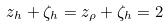<formula> <loc_0><loc_0><loc_500><loc_500>z _ { h } + \zeta _ { h } = z _ { \rho } + \zeta _ { h } = 2</formula> 